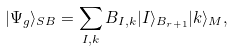<formula> <loc_0><loc_0><loc_500><loc_500>| \Psi _ { g } \rangle _ { S B } = \sum _ { I , k } B _ { I , k } | I \rangle _ { B _ { r + 1 } } | k \rangle _ { M } ,</formula> 